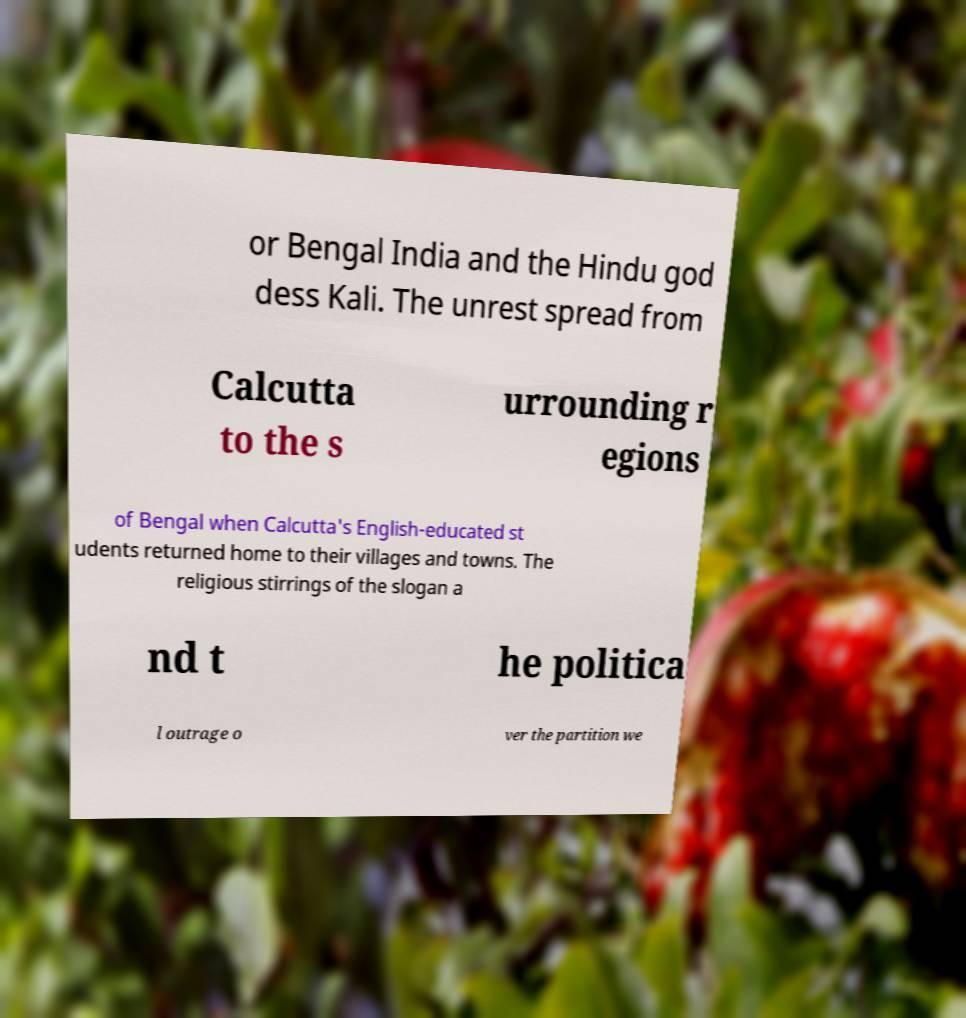What messages or text are displayed in this image? I need them in a readable, typed format. or Bengal India and the Hindu god dess Kali. The unrest spread from Calcutta to the s urrounding r egions of Bengal when Calcutta's English-educated st udents returned home to their villages and towns. The religious stirrings of the slogan a nd t he politica l outrage o ver the partition we 